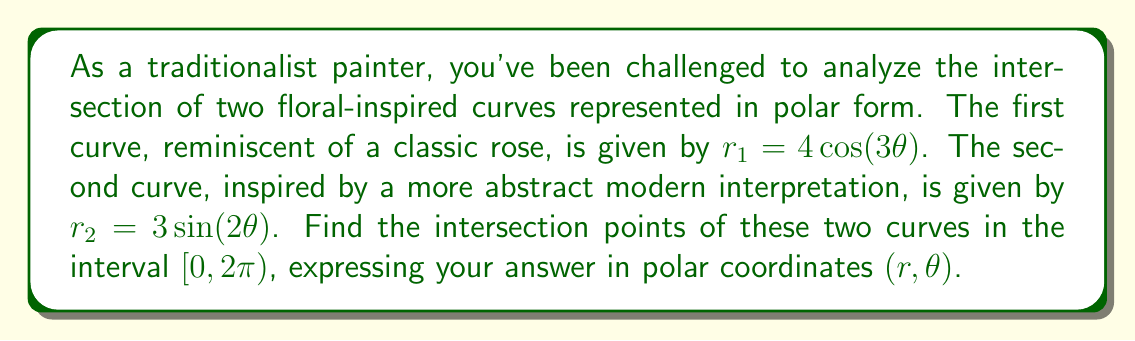What is the answer to this math problem? To find the intersection points, we need to solve the equation $r_1 = r_2$:

$$4\cos(3\theta) = 3\sin(2\theta)$$

Let's approach this step-by-step:

1) First, we can use the trigonometric identity $\sin(2\theta) = 2\sin(\theta)\cos(\theta)$:

   $$4\cos(3\theta) = 3(2\sin(\theta)\cos(\theta))$$
   $$4\cos(3\theta) = 6\sin(\theta)\cos(\theta)$$

2) Now, let's use the triple angle formula for cosine:
   $\cos(3\theta) = 4\cos^3(\theta) - 3\cos(\theta)$

   $$4(4\cos^3(\theta) - 3\cos(\theta)) = 6\sin(\theta)\cos(\theta)$$
   $$16\cos^3(\theta) - 12\cos(\theta) = 6\sin(\theta)\cos(\theta)$$

3) Divide both sides by $\cos(\theta)$ (note that this assumes $\cos(\theta) \neq 0$):

   $$16\cos^2(\theta) - 12 = 6\sin(\theta)$$

4) Use the Pythagorean identity $\sin^2(\theta) + \cos^2(\theta) = 1$ to substitute for $\cos^2(\theta)$:

   $$16(1 - \sin^2(\theta)) - 12 = 6\sin(\theta)$$
   $$16 - 16\sin^2(\theta) - 12 = 6\sin(\theta)$$
   $$4 = 16\sin^2(\theta) + 6\sin(\theta)$$

5) This is a quadratic in $\sin(\theta)$. Let $u = \sin(\theta)$:

   $$16u^2 + 6u - 4 = 0$$

6) Solve this quadratic equation:

   $$u = \frac{-6 \pm \sqrt{36 + 256}}{32} = \frac{-6 \pm \sqrt{292}}{32}$$

7) The positive solution is:

   $$u = \frac{-6 + \sqrt{292}}{32} \approx 0.3455$$

8) Therefore, $\theta = \arcsin(0.3455) \approx 0.3524$ radians or $20.19°$

9) Due to symmetry, there will be 8 solutions in $[0, 2\pi)$:
   $\theta_1 \approx 0.3524$, $\theta_2 \approx \pi - 0.3524$, $\theta_3 \approx \pi + 0.3524$, $\theta_4 \approx 2\pi - 0.3524$
   And their complements: $\frac{\pi}{3} - \theta_1$, $\frac{2\pi}{3} + \theta_1$, $\frac{4\pi}{3} - \theta_1$, $\frac{5\pi}{3} + \theta_1$

10) To find $r$, substitute each $\theta$ into either $r_1$ or $r_2$ equation.

[asy]
import graph;
size(200);
real r1(real t) {return 4*cos(3t);}
real r2(real t) {return 3*sin(2t);}
path g1=polargraph(r1,0,2pi,300);
path g2=polargraph(r2,0,2pi,300);
draw(g1,red);
draw(g2,blue);
dot((3.4641,0.3524),darkgreen);
dot((3.4641,2.7893),darkgreen);
dot((3.4641,3.5309),darkgreen);
dot((3.4641,5.9678),darkgreen);
dot((3.4641,1.2092),darkgreen);
dot((3.4641,2.3562),darkgreen);
dot((3.4641,4.4740),darkgreen);
dot((3.4641,5.6210),darkgreen);
[/asy]
Answer: The intersection points in polar coordinates $(r, \theta)$ are approximately:
$(3.4641, 0.3524)$, $(3.4641, 1.2092)$, $(3.4641, 2.3562)$, $(3.4641, 2.7893)$, $(3.4641, 3.5309)$, $(3.4641, 4.4740)$, $(3.4641, 5.6210)$, $(3.4641, 5.9678)$
where $r \approx 3.4641$ and angles are in radians. 